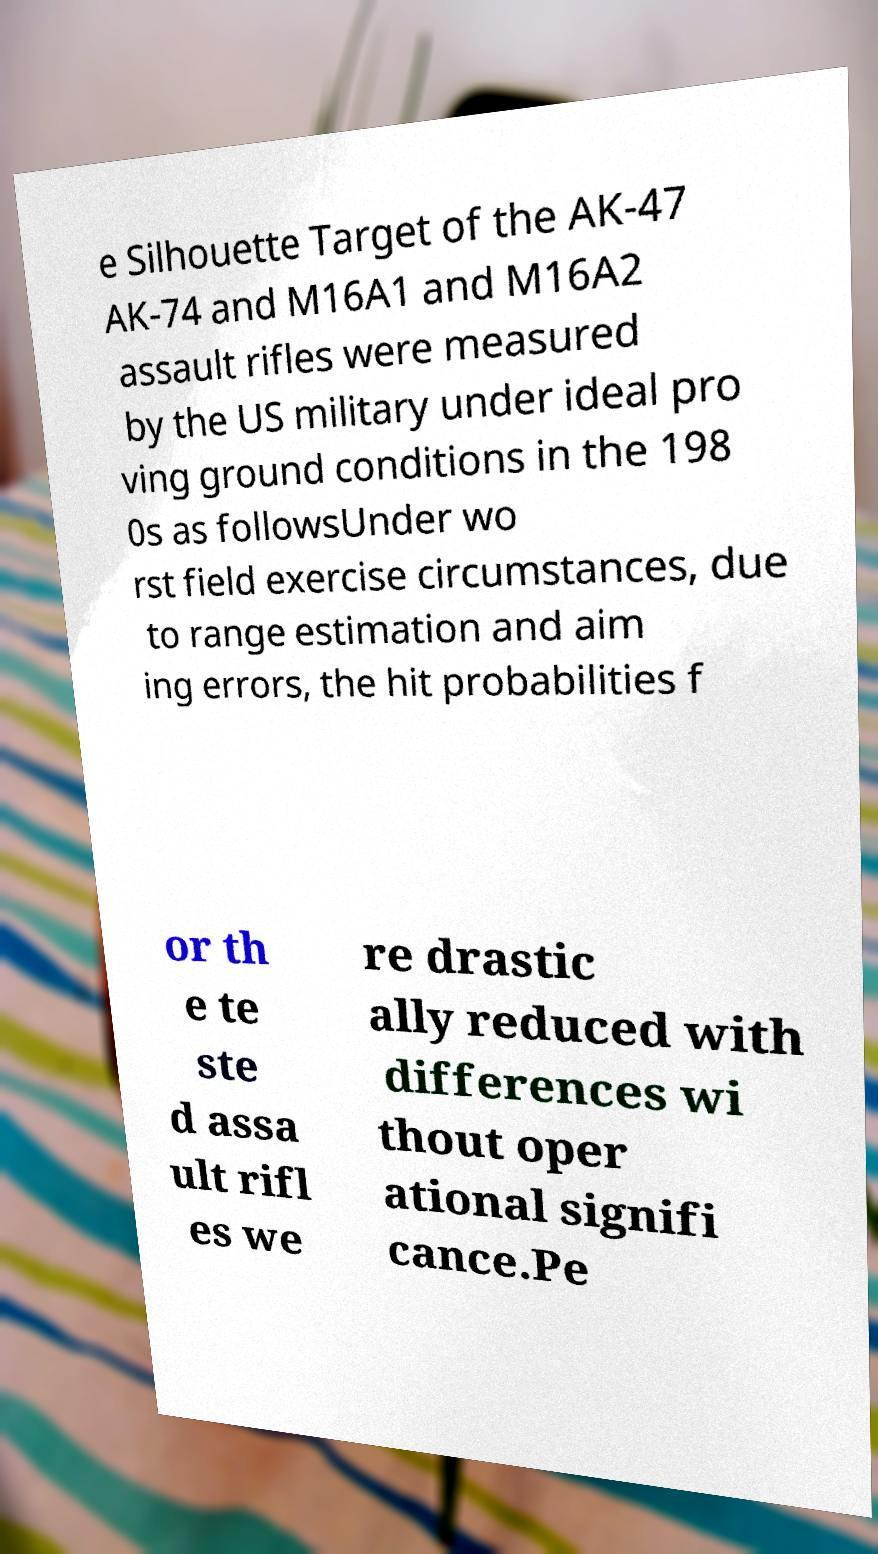Can you read and provide the text displayed in the image?This photo seems to have some interesting text. Can you extract and type it out for me? e Silhouette Target of the AK-47 AK-74 and M16A1 and M16A2 assault rifles were measured by the US military under ideal pro ving ground conditions in the 198 0s as followsUnder wo rst field exercise circumstances, due to range estimation and aim ing errors, the hit probabilities f or th e te ste d assa ult rifl es we re drastic ally reduced with differences wi thout oper ational signifi cance.Pe 